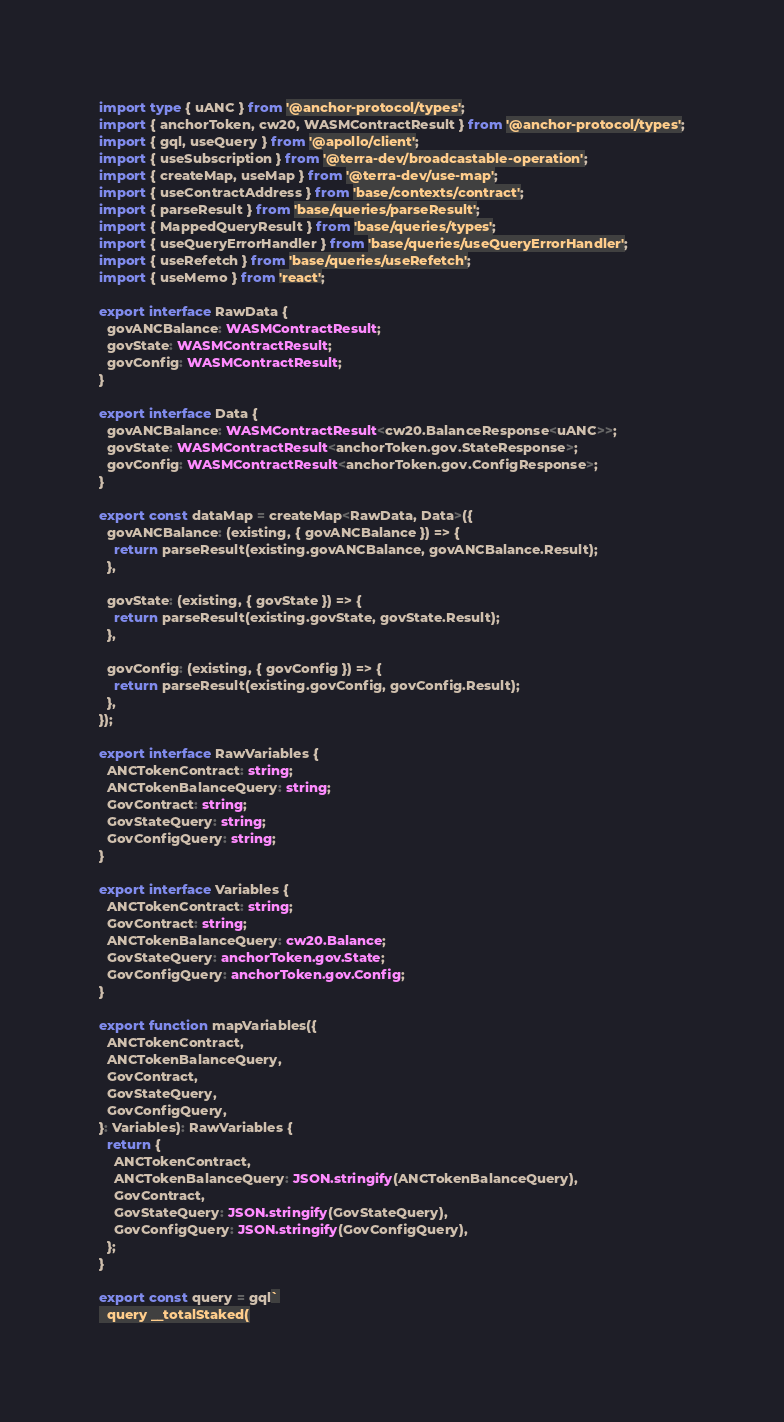Convert code to text. <code><loc_0><loc_0><loc_500><loc_500><_TypeScript_>import type { uANC } from '@anchor-protocol/types';
import { anchorToken, cw20, WASMContractResult } from '@anchor-protocol/types';
import { gql, useQuery } from '@apollo/client';
import { useSubscription } from '@terra-dev/broadcastable-operation';
import { createMap, useMap } from '@terra-dev/use-map';
import { useContractAddress } from 'base/contexts/contract';
import { parseResult } from 'base/queries/parseResult';
import { MappedQueryResult } from 'base/queries/types';
import { useQueryErrorHandler } from 'base/queries/useQueryErrorHandler';
import { useRefetch } from 'base/queries/useRefetch';
import { useMemo } from 'react';

export interface RawData {
  govANCBalance: WASMContractResult;
  govState: WASMContractResult;
  govConfig: WASMContractResult;
}

export interface Data {
  govANCBalance: WASMContractResult<cw20.BalanceResponse<uANC>>;
  govState: WASMContractResult<anchorToken.gov.StateResponse>;
  govConfig: WASMContractResult<anchorToken.gov.ConfigResponse>;
}

export const dataMap = createMap<RawData, Data>({
  govANCBalance: (existing, { govANCBalance }) => {
    return parseResult(existing.govANCBalance, govANCBalance.Result);
  },

  govState: (existing, { govState }) => {
    return parseResult(existing.govState, govState.Result);
  },

  govConfig: (existing, { govConfig }) => {
    return parseResult(existing.govConfig, govConfig.Result);
  },
});

export interface RawVariables {
  ANCTokenContract: string;
  ANCTokenBalanceQuery: string;
  GovContract: string;
  GovStateQuery: string;
  GovConfigQuery: string;
}

export interface Variables {
  ANCTokenContract: string;
  GovContract: string;
  ANCTokenBalanceQuery: cw20.Balance;
  GovStateQuery: anchorToken.gov.State;
  GovConfigQuery: anchorToken.gov.Config;
}

export function mapVariables({
  ANCTokenContract,
  ANCTokenBalanceQuery,
  GovContract,
  GovStateQuery,
  GovConfigQuery,
}: Variables): RawVariables {
  return {
    ANCTokenContract,
    ANCTokenBalanceQuery: JSON.stringify(ANCTokenBalanceQuery),
    GovContract,
    GovStateQuery: JSON.stringify(GovStateQuery),
    GovConfigQuery: JSON.stringify(GovConfigQuery),
  };
}

export const query = gql`
  query __totalStaked(</code> 